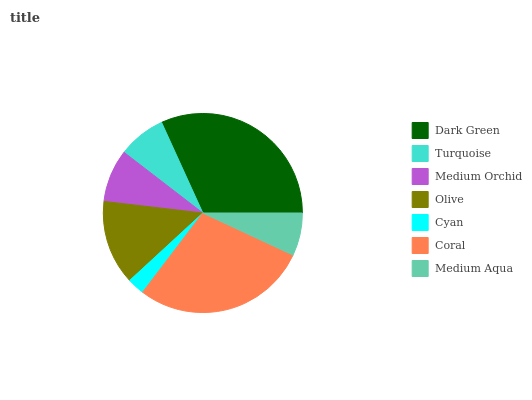Is Cyan the minimum?
Answer yes or no. Yes. Is Dark Green the maximum?
Answer yes or no. Yes. Is Turquoise the minimum?
Answer yes or no. No. Is Turquoise the maximum?
Answer yes or no. No. Is Dark Green greater than Turquoise?
Answer yes or no. Yes. Is Turquoise less than Dark Green?
Answer yes or no. Yes. Is Turquoise greater than Dark Green?
Answer yes or no. No. Is Dark Green less than Turquoise?
Answer yes or no. No. Is Medium Orchid the high median?
Answer yes or no. Yes. Is Medium Orchid the low median?
Answer yes or no. Yes. Is Medium Aqua the high median?
Answer yes or no. No. Is Cyan the low median?
Answer yes or no. No. 